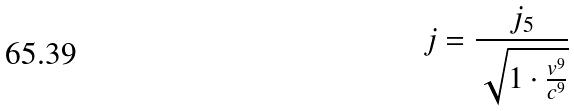<formula> <loc_0><loc_0><loc_500><loc_500>j = \frac { j _ { 5 } } { \sqrt { 1 \cdot \frac { v ^ { 9 } } { c ^ { 9 } } } }</formula> 